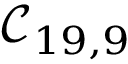Convert formula to latex. <formula><loc_0><loc_0><loc_500><loc_500>\mathcal { C } _ { 1 9 , 9 }</formula> 